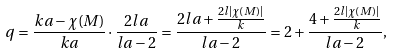Convert formula to latex. <formula><loc_0><loc_0><loc_500><loc_500>q = \frac { k a - \chi ( M ) } { k a } \cdot \frac { 2 l a } { l a - 2 } = \frac { 2 l a + \frac { 2 l | \chi ( M ) | } { k } } { l a - 2 } = 2 + \frac { 4 + \frac { 2 l | \chi ( M ) | } { k } } { l a - 2 } ,</formula> 